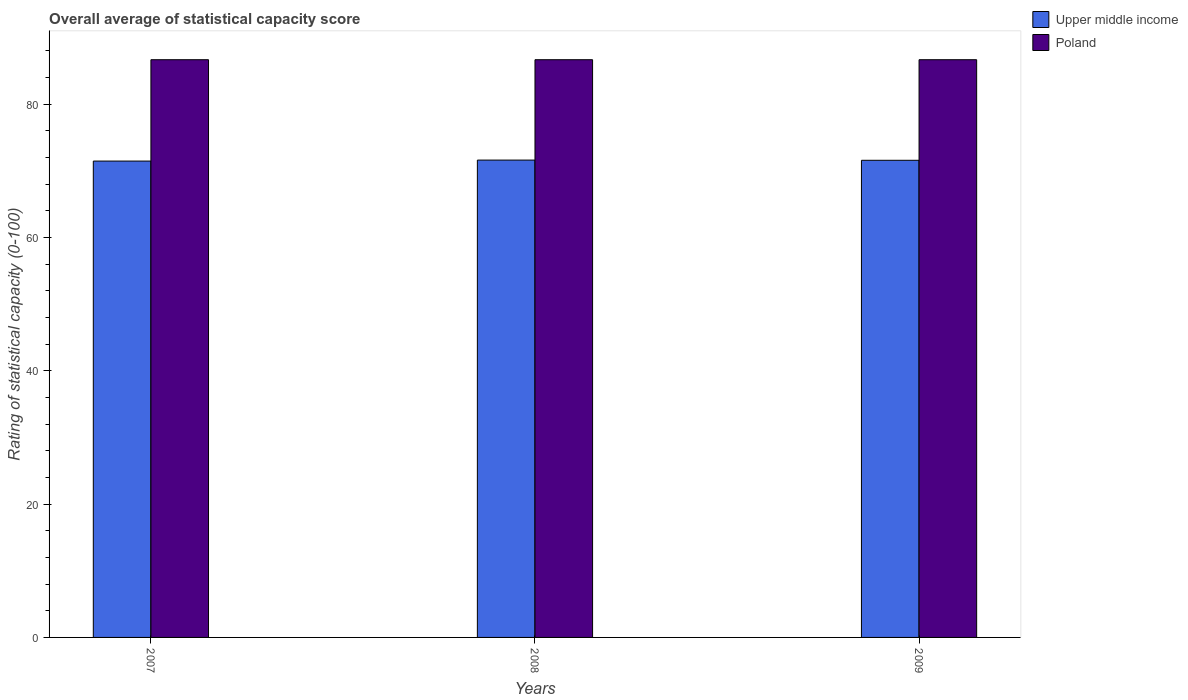How many groups of bars are there?
Keep it short and to the point. 3. Are the number of bars per tick equal to the number of legend labels?
Your response must be concise. Yes. How many bars are there on the 2nd tick from the left?
Your answer should be compact. 2. What is the rating of statistical capacity in Poland in 2009?
Provide a succinct answer. 86.67. Across all years, what is the maximum rating of statistical capacity in Poland?
Offer a terse response. 86.67. Across all years, what is the minimum rating of statistical capacity in Upper middle income?
Provide a succinct answer. 71.46. In which year was the rating of statistical capacity in Poland maximum?
Make the answer very short. 2007. What is the total rating of statistical capacity in Upper middle income in the graph?
Give a very brief answer. 214.65. What is the difference between the rating of statistical capacity in Upper middle income in 2007 and that in 2009?
Make the answer very short. -0.12. What is the difference between the rating of statistical capacity in Upper middle income in 2008 and the rating of statistical capacity in Poland in 2007?
Offer a very short reply. -15.06. What is the average rating of statistical capacity in Poland per year?
Give a very brief answer. 86.67. In the year 2008, what is the difference between the rating of statistical capacity in Upper middle income and rating of statistical capacity in Poland?
Provide a succinct answer. -15.06. What is the ratio of the rating of statistical capacity in Upper middle income in 2007 to that in 2009?
Provide a succinct answer. 1. Is the difference between the rating of statistical capacity in Upper middle income in 2007 and 2009 greater than the difference between the rating of statistical capacity in Poland in 2007 and 2009?
Your answer should be very brief. No. What is the difference between the highest and the second highest rating of statistical capacity in Upper middle income?
Your answer should be very brief. 0.03. What is the difference between the highest and the lowest rating of statistical capacity in Upper middle income?
Your answer should be compact. 0.15. Is the sum of the rating of statistical capacity in Poland in 2008 and 2009 greater than the maximum rating of statistical capacity in Upper middle income across all years?
Provide a succinct answer. Yes. What does the 1st bar from the right in 2009 represents?
Keep it short and to the point. Poland. What is the difference between two consecutive major ticks on the Y-axis?
Give a very brief answer. 20. Are the values on the major ticks of Y-axis written in scientific E-notation?
Your response must be concise. No. Does the graph contain any zero values?
Offer a very short reply. No. Does the graph contain grids?
Your answer should be compact. No. How are the legend labels stacked?
Offer a very short reply. Vertical. What is the title of the graph?
Keep it short and to the point. Overall average of statistical capacity score. What is the label or title of the X-axis?
Ensure brevity in your answer.  Years. What is the label or title of the Y-axis?
Your answer should be compact. Rating of statistical capacity (0-100). What is the Rating of statistical capacity (0-100) of Upper middle income in 2007?
Give a very brief answer. 71.46. What is the Rating of statistical capacity (0-100) of Poland in 2007?
Give a very brief answer. 86.67. What is the Rating of statistical capacity (0-100) of Upper middle income in 2008?
Provide a short and direct response. 71.61. What is the Rating of statistical capacity (0-100) in Poland in 2008?
Offer a terse response. 86.67. What is the Rating of statistical capacity (0-100) of Upper middle income in 2009?
Keep it short and to the point. 71.58. What is the Rating of statistical capacity (0-100) in Poland in 2009?
Provide a succinct answer. 86.67. Across all years, what is the maximum Rating of statistical capacity (0-100) in Upper middle income?
Give a very brief answer. 71.61. Across all years, what is the maximum Rating of statistical capacity (0-100) in Poland?
Give a very brief answer. 86.67. Across all years, what is the minimum Rating of statistical capacity (0-100) in Upper middle income?
Your answer should be compact. 71.46. Across all years, what is the minimum Rating of statistical capacity (0-100) of Poland?
Make the answer very short. 86.67. What is the total Rating of statistical capacity (0-100) of Upper middle income in the graph?
Keep it short and to the point. 214.65. What is the total Rating of statistical capacity (0-100) in Poland in the graph?
Give a very brief answer. 260. What is the difference between the Rating of statistical capacity (0-100) in Upper middle income in 2007 and that in 2008?
Give a very brief answer. -0.15. What is the difference between the Rating of statistical capacity (0-100) in Upper middle income in 2007 and that in 2009?
Provide a short and direct response. -0.12. What is the difference between the Rating of statistical capacity (0-100) of Upper middle income in 2008 and that in 2009?
Your answer should be very brief. 0.03. What is the difference between the Rating of statistical capacity (0-100) of Upper middle income in 2007 and the Rating of statistical capacity (0-100) of Poland in 2008?
Your answer should be compact. -15.2. What is the difference between the Rating of statistical capacity (0-100) in Upper middle income in 2007 and the Rating of statistical capacity (0-100) in Poland in 2009?
Your response must be concise. -15.2. What is the difference between the Rating of statistical capacity (0-100) of Upper middle income in 2008 and the Rating of statistical capacity (0-100) of Poland in 2009?
Offer a terse response. -15.06. What is the average Rating of statistical capacity (0-100) of Upper middle income per year?
Give a very brief answer. 71.55. What is the average Rating of statistical capacity (0-100) in Poland per year?
Keep it short and to the point. 86.67. In the year 2007, what is the difference between the Rating of statistical capacity (0-100) of Upper middle income and Rating of statistical capacity (0-100) of Poland?
Keep it short and to the point. -15.2. In the year 2008, what is the difference between the Rating of statistical capacity (0-100) of Upper middle income and Rating of statistical capacity (0-100) of Poland?
Ensure brevity in your answer.  -15.06. In the year 2009, what is the difference between the Rating of statistical capacity (0-100) of Upper middle income and Rating of statistical capacity (0-100) of Poland?
Give a very brief answer. -15.09. What is the ratio of the Rating of statistical capacity (0-100) in Upper middle income in 2007 to that in 2008?
Provide a succinct answer. 1. What is the ratio of the Rating of statistical capacity (0-100) of Upper middle income in 2007 to that in 2009?
Your answer should be very brief. 1. What is the ratio of the Rating of statistical capacity (0-100) of Upper middle income in 2008 to that in 2009?
Your response must be concise. 1. What is the ratio of the Rating of statistical capacity (0-100) of Poland in 2008 to that in 2009?
Give a very brief answer. 1. What is the difference between the highest and the second highest Rating of statistical capacity (0-100) in Upper middle income?
Provide a short and direct response. 0.03. What is the difference between the highest and the second highest Rating of statistical capacity (0-100) of Poland?
Your answer should be very brief. 0. What is the difference between the highest and the lowest Rating of statistical capacity (0-100) of Upper middle income?
Offer a terse response. 0.15. 